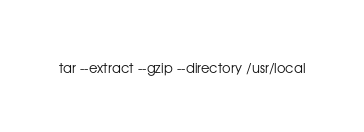Convert code to text. <code><loc_0><loc_0><loc_500><loc_500><_Bash_>tar --extract --gzip --directory /usr/local
</code> 